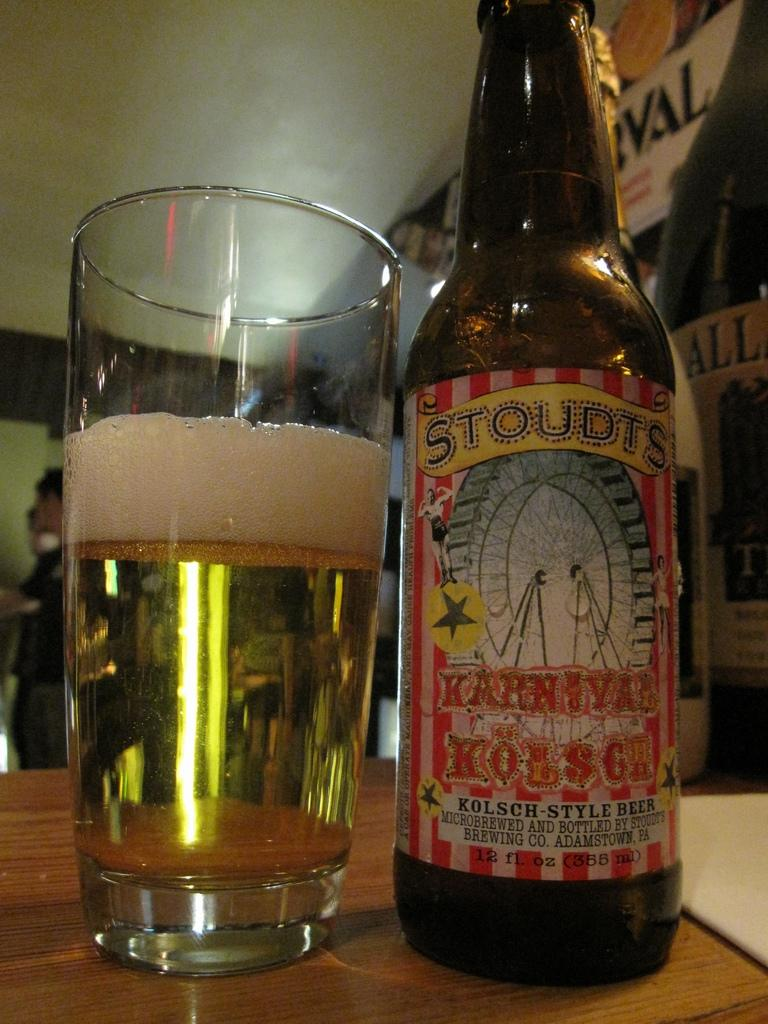<image>
Render a clear and concise summary of the photo. A bottle of Kolsch- Style beer by Stoudts sitting on a counter of a busy bar. 